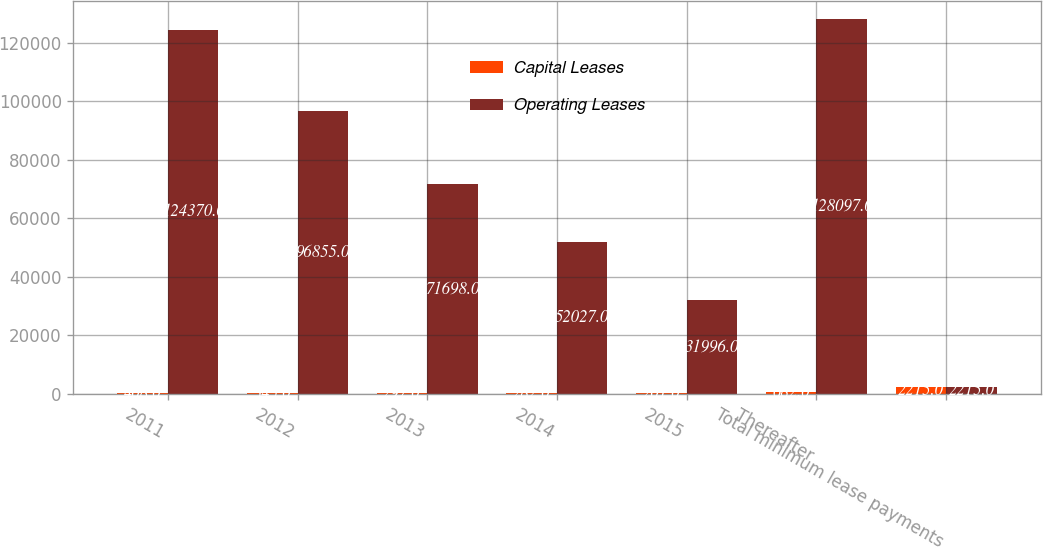Convert chart. <chart><loc_0><loc_0><loc_500><loc_500><stacked_bar_chart><ecel><fcel>2011<fcel>2012<fcel>2013<fcel>2014<fcel>2015<fcel>Thereafter<fcel>Total minimum lease payments<nl><fcel>Capital Leases<fcel>408<fcel>345<fcel>297<fcel>282<fcel>201<fcel>682<fcel>2215<nl><fcel>Operating Leases<fcel>124370<fcel>96855<fcel>71698<fcel>52027<fcel>31996<fcel>128097<fcel>2215<nl></chart> 